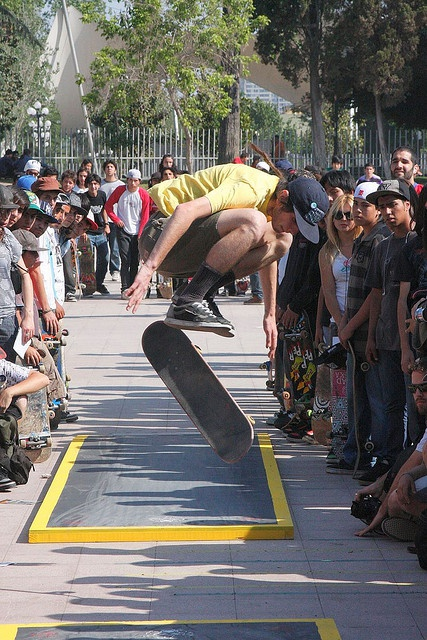Describe the objects in this image and their specific colors. I can see people in gray, black, lightgray, and maroon tones, people in gray, black, beige, and khaki tones, people in gray, black, maroon, and brown tones, skateboard in gray and black tones, and people in gray, black, lightgray, and darkgray tones in this image. 